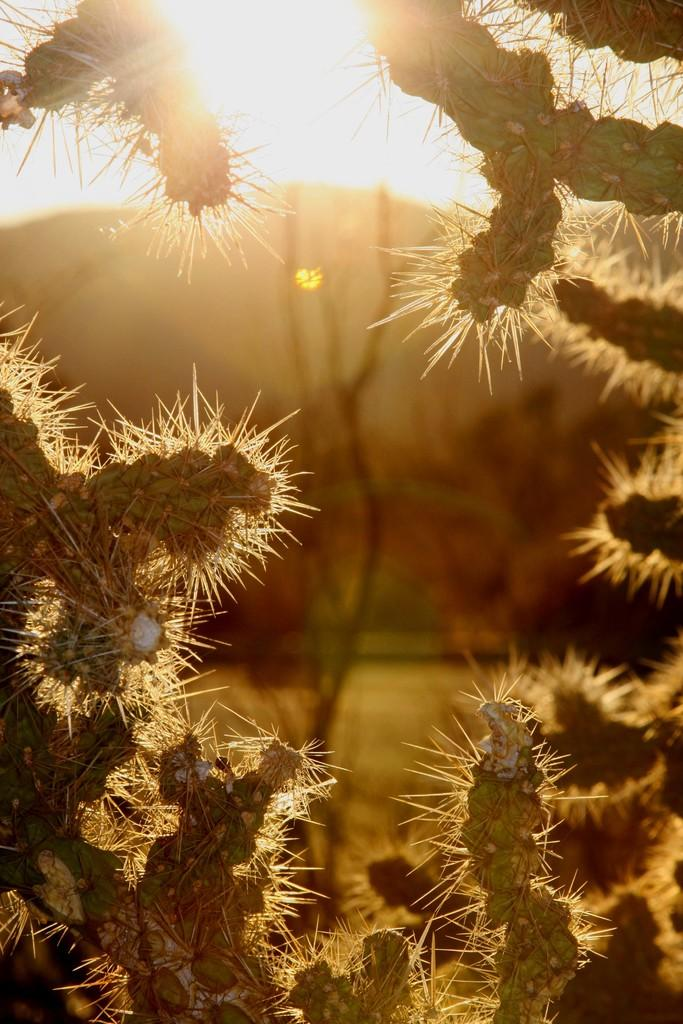What type of plants are in the image? There are cactus plants in the image. What is visible at the top of the image? Sunlight is visible at the top of the image. What type of acoustics can be heard in the image? There is no sound or acoustics present in the image, as it is a still image of cactus plants and sunlight. 